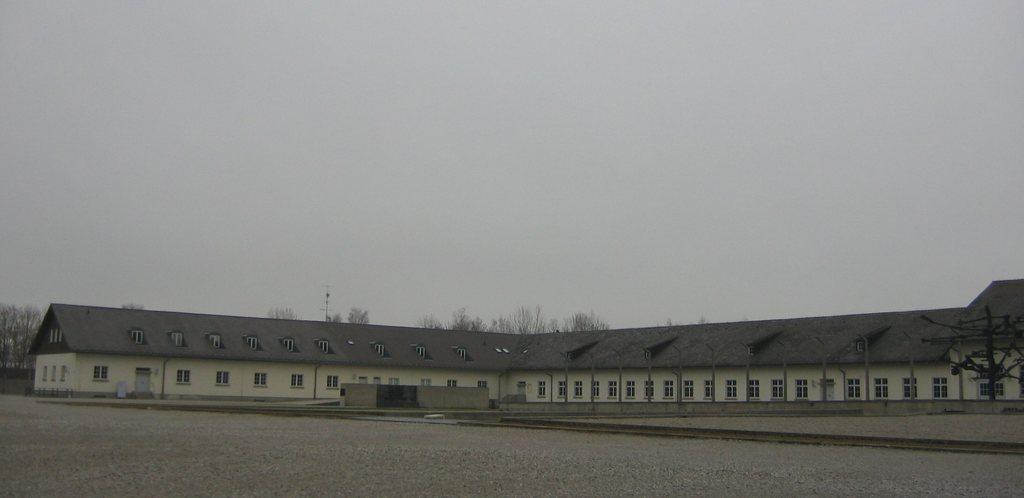What structure is present in the image? There is a building in the image. What feature can be observed on the building? The building has windows. What type of vegetation is visible in the image? There are trees in the image. What is visible in the background of the image? The sky is visible in the background of the image. How does the pump move around in the image? There is no pump present in the image. What type of rod can be seen interacting with the trees in the image? There is no rod interacting with the trees in the image. 